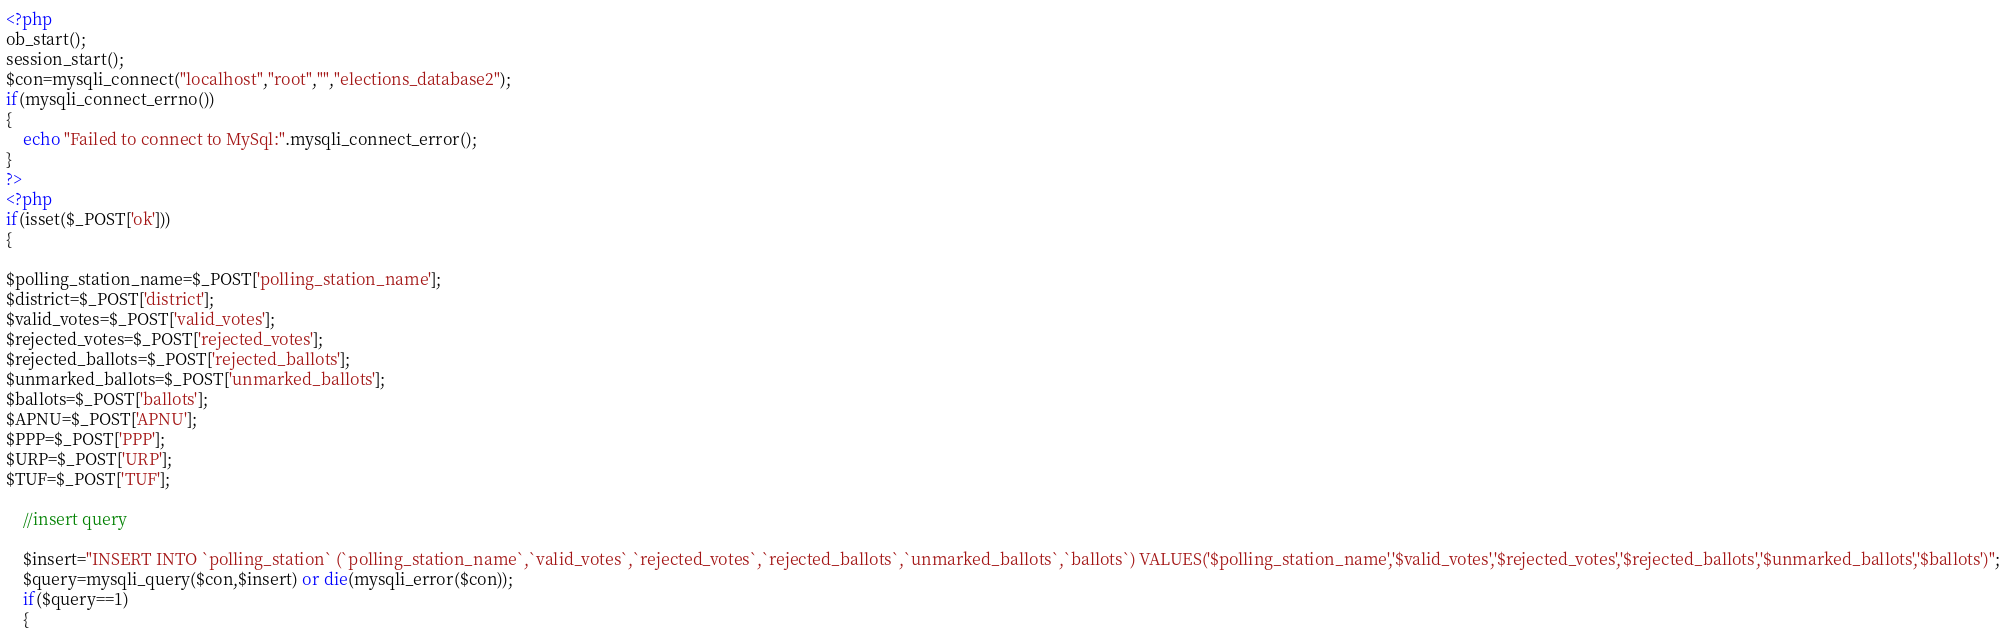Convert code to text. <code><loc_0><loc_0><loc_500><loc_500><_PHP_><?php
ob_start();
session_start();
$con=mysqli_connect("localhost","root","","elections_database2");
if(mysqli_connect_errno())
{
	echo "Failed to connect to MySql:".mysqli_connect_error();
}
?>
<?php
if(isset($_POST['ok']))
{

$polling_station_name=$_POST['polling_station_name'];
$district=$_POST['district'];
$valid_votes=$_POST['valid_votes'];
$rejected_votes=$_POST['rejected_votes'];
$rejected_ballots=$_POST['rejected_ballots'];
$unmarked_ballots=$_POST['unmarked_ballots'];
$ballots=$_POST['ballots'];
$APNU=$_POST['APNU'];
$PPP=$_POST['PPP'];
$URP=$_POST['URP'];
$TUF=$_POST['TUF'];

	//insert query

	$insert="INSERT INTO `polling_station` (`polling_station_name`,`valid_votes`,`rejected_votes`,`rejected_ballots`,`unmarked_ballots`,`ballots`) VALUES('$polling_station_name','$valid_votes','$rejected_votes','$rejected_ballots','$unmarked_ballots','$ballots')";
	$query=mysqli_query($con,$insert) or die(mysqli_error($con));
	if($query==1)
	{</code> 